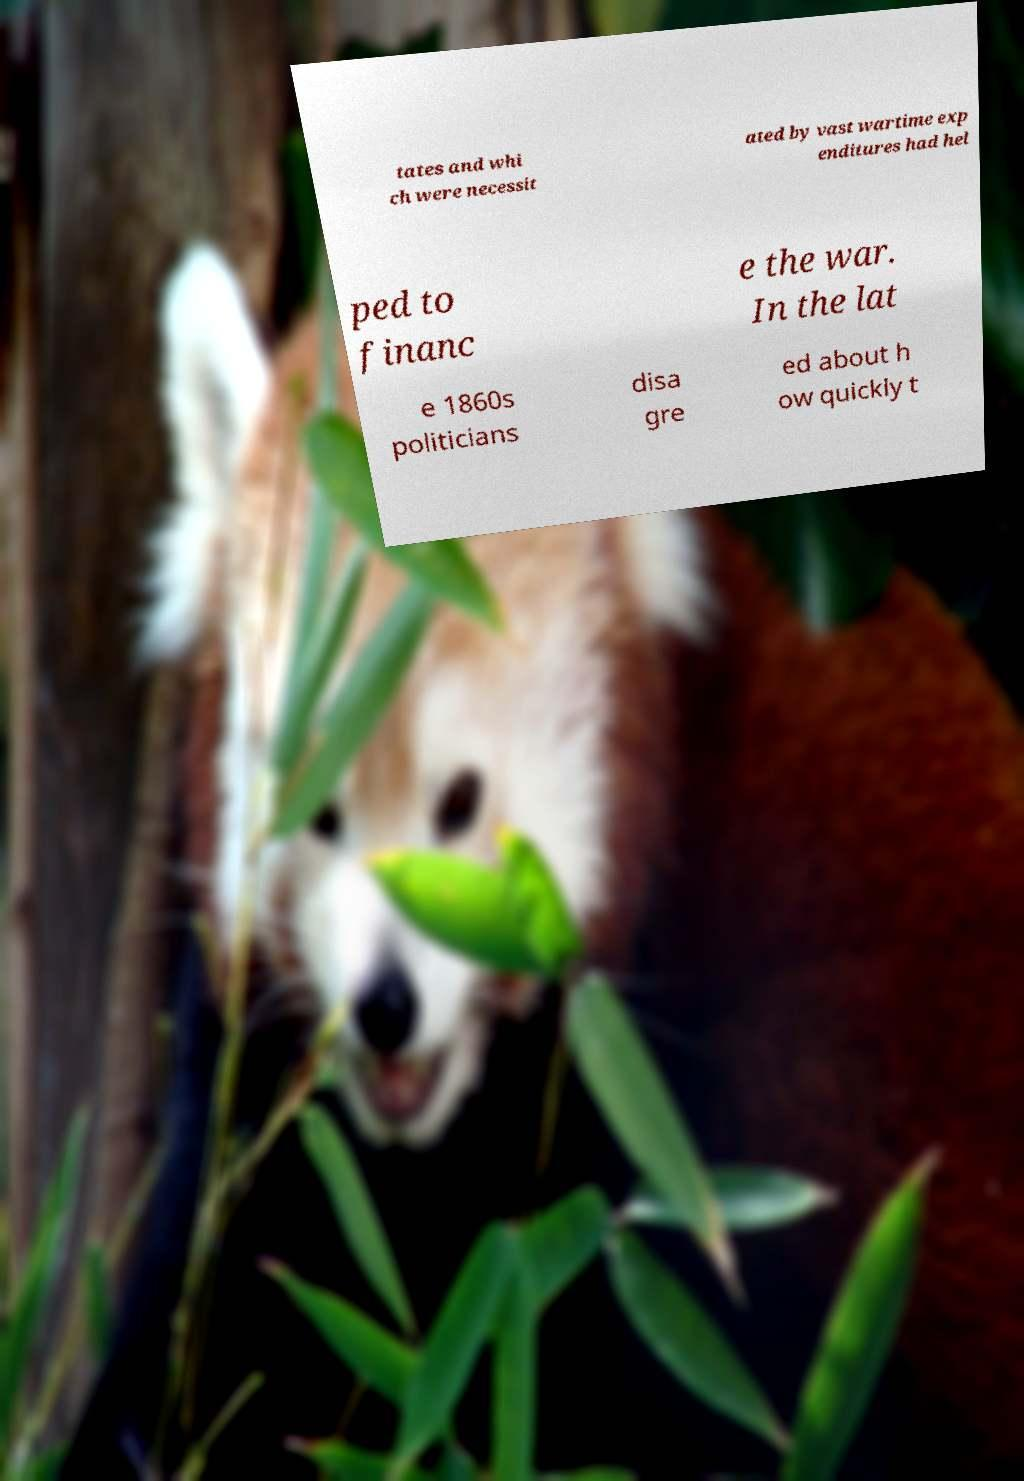Could you extract and type out the text from this image? tates and whi ch were necessit ated by vast wartime exp enditures had hel ped to financ e the war. In the lat e 1860s politicians disa gre ed about h ow quickly t 